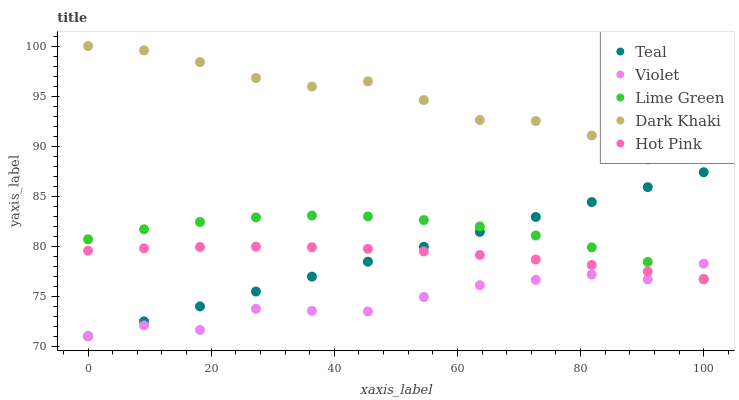Does Violet have the minimum area under the curve?
Answer yes or no. Yes. Does Dark Khaki have the maximum area under the curve?
Answer yes or no. Yes. Does Hot Pink have the minimum area under the curve?
Answer yes or no. No. Does Hot Pink have the maximum area under the curve?
Answer yes or no. No. Is Teal the smoothest?
Answer yes or no. Yes. Is Dark Khaki the roughest?
Answer yes or no. Yes. Is Hot Pink the smoothest?
Answer yes or no. No. Is Hot Pink the roughest?
Answer yes or no. No. Does Teal have the lowest value?
Answer yes or no. Yes. Does Hot Pink have the lowest value?
Answer yes or no. No. Does Dark Khaki have the highest value?
Answer yes or no. Yes. Does Hot Pink have the highest value?
Answer yes or no. No. Is Hot Pink less than Dark Khaki?
Answer yes or no. Yes. Is Dark Khaki greater than Hot Pink?
Answer yes or no. Yes. Does Violet intersect Hot Pink?
Answer yes or no. Yes. Is Violet less than Hot Pink?
Answer yes or no. No. Is Violet greater than Hot Pink?
Answer yes or no. No. Does Hot Pink intersect Dark Khaki?
Answer yes or no. No. 